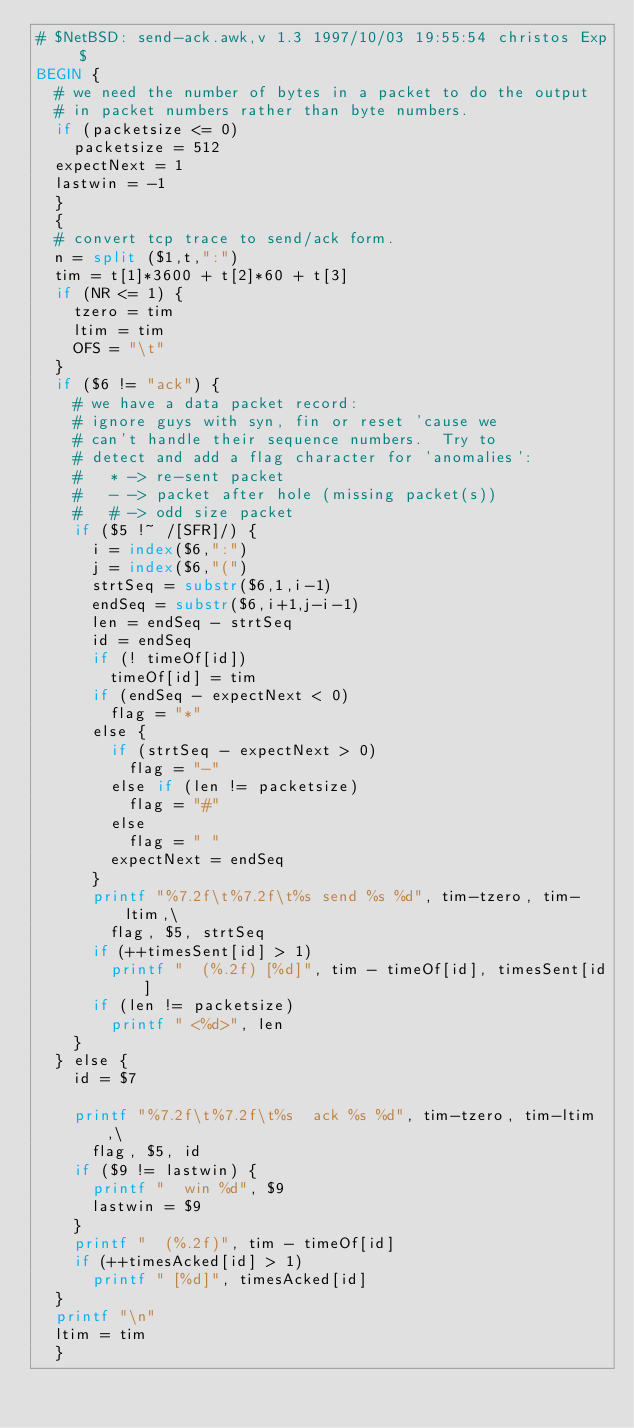Convert code to text. <code><loc_0><loc_0><loc_500><loc_500><_Awk_>#	$NetBSD: send-ack.awk,v 1.3 1997/10/03 19:55:54 christos Exp $
BEGIN	{
	# we need the number of bytes in a packet to do the output
	# in packet numbers rather than byte numbers.
	if (packetsize <= 0)
		packetsize = 512
	expectNext = 1
	lastwin = -1
	}
	{
	# convert tcp trace to send/ack form.
	n = split ($1,t,":")
	tim = t[1]*3600 + t[2]*60 + t[3]
	if (NR <= 1) {
		tzero = tim
		ltim = tim
		OFS = "\t"
	}
	if ($6 != "ack") {
		# we have a data packet record:
		# ignore guys with syn, fin or reset 'cause we
		# can't handle their sequence numbers.  Try to
		# detect and add a flag character for 'anomalies':
		#   * -> re-sent packet
		#   - -> packet after hole (missing packet(s))
		#   # -> odd size packet
		if ($5 !~ /[SFR]/) {
			i = index($6,":")
			j = index($6,"(")
			strtSeq = substr($6,1,i-1)
			endSeq = substr($6,i+1,j-i-1)
			len = endSeq - strtSeq
			id = endSeq
			if (! timeOf[id])
				timeOf[id] = tim
			if (endSeq - expectNext < 0)
				flag = "*"
			else {
				if (strtSeq - expectNext > 0)
					flag = "-"
				else if (len != packetsize)
					flag = "#"
				else
					flag = " "
				expectNext = endSeq
			}
			printf "%7.2f\t%7.2f\t%s send %s %d", tim-tzero, tim-ltim,\
				flag, $5, strtSeq
			if (++timesSent[id] > 1)
				printf "  (%.2f) [%d]", tim - timeOf[id], timesSent[id]
			if (len != packetsize)
				printf " <%d>", len
		}
	} else {
		id = $7

		printf "%7.2f\t%7.2f\t%s  ack %s %d", tim-tzero, tim-ltim,\
			flag, $5, id
		if ($9 != lastwin) {
			printf "  win %d", $9
			lastwin = $9
		}
		printf "  (%.2f)", tim - timeOf[id]
		if (++timesAcked[id] > 1)
			printf " [%d]", timesAcked[id]
	}
	printf "\n"
	ltim = tim
	}
</code> 